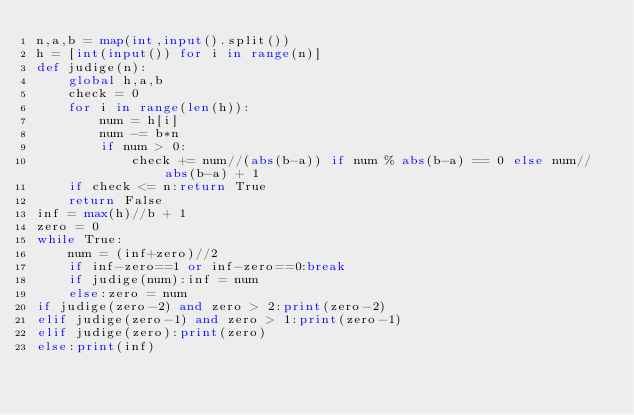Convert code to text. <code><loc_0><loc_0><loc_500><loc_500><_Python_>n,a,b = map(int,input().split())
h = [int(input()) for i in range(n)]
def judige(n):
    global h,a,b
    check = 0
    for i in range(len(h)):
        num = h[i]
        num -= b*n
        if num > 0:
            check += num//(abs(b-a)) if num % abs(b-a) == 0 else num//abs(b-a) + 1
    if check <= n:return True
    return False
inf = max(h)//b + 1
zero = 0
while True:
    num = (inf+zero)//2
    if inf-zero==1 or inf-zero==0:break
    if judige(num):inf = num
    else:zero = num
if judige(zero-2) and zero > 2:print(zero-2)
elif judige(zero-1) and zero > 1:print(zero-1)
elif judige(zero):print(zero)
else:print(inf)</code> 